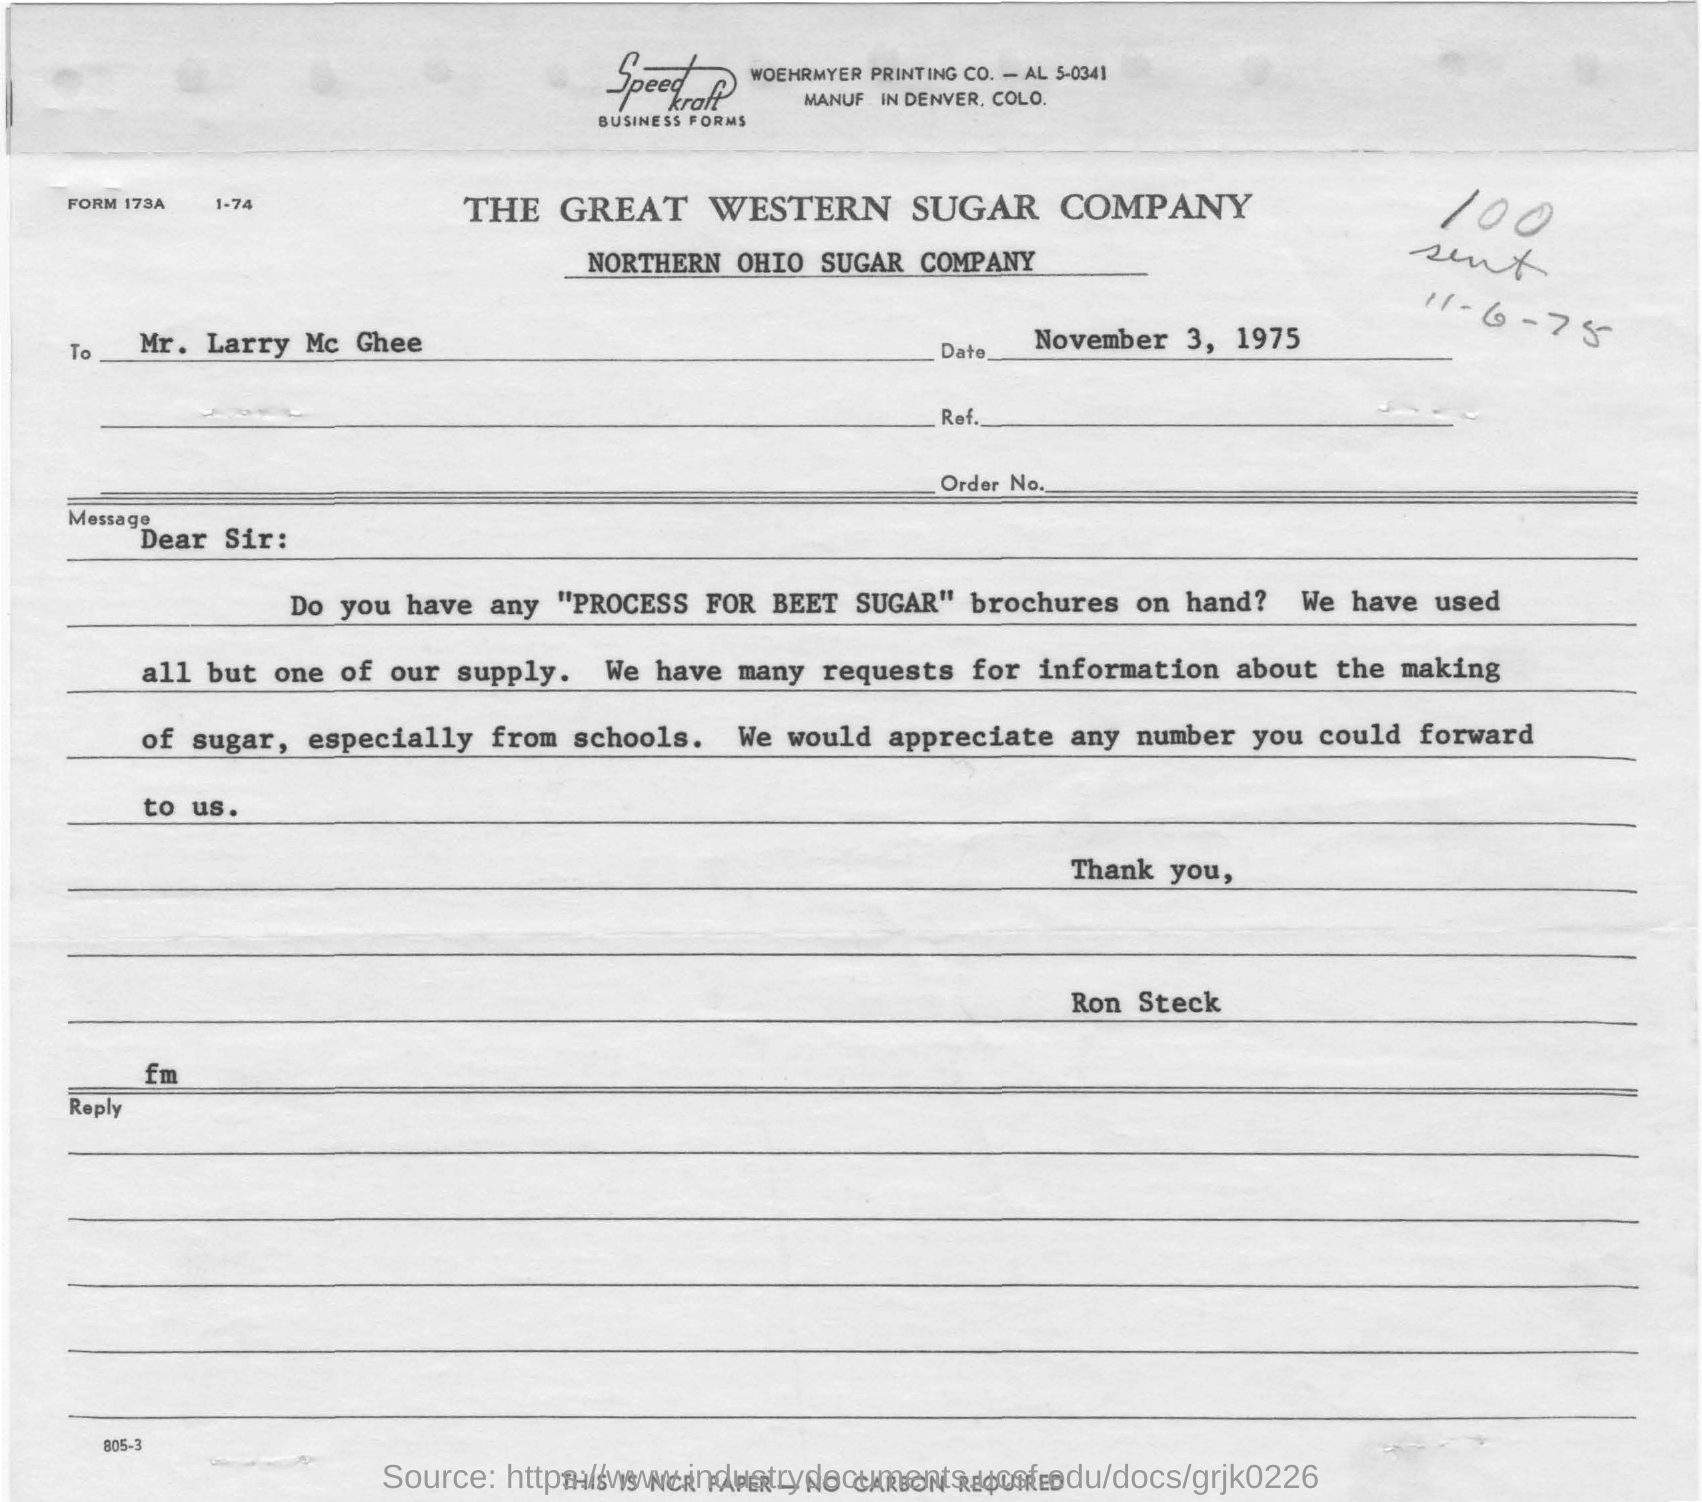From where are they having many requests for information about making of sugar? According to the letter addressed to Mr. Larry McGhee dated November 3, 1975, the requests for information about the making of sugar, specifically beet sugar, are coming primarily from schools. The senders have nearly exhausted their supply of 'PROCESS FOR BEET SUGAR' brochures and are seeking additional copies to satisfy these educational inquiries. 